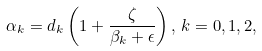Convert formula to latex. <formula><loc_0><loc_0><loc_500><loc_500>\alpha _ { k } = d _ { k } \left ( 1 + \frac { \zeta } { \beta _ { k } + \epsilon } \right ) , \, k = 0 , 1 , 2 ,</formula> 